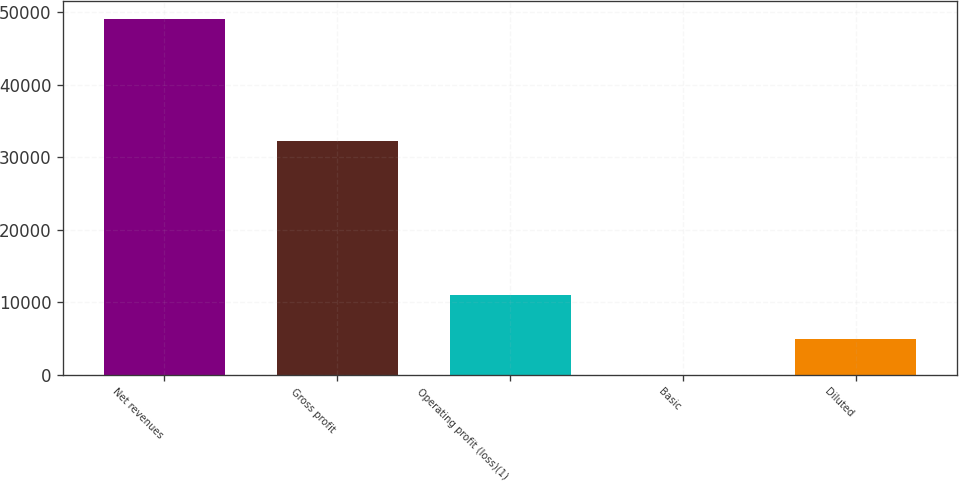Convert chart to OTSL. <chart><loc_0><loc_0><loc_500><loc_500><bar_chart><fcel>Net revenues<fcel>Gross profit<fcel>Operating profit (loss)(1)<fcel>Basic<fcel>Diluted<nl><fcel>49034<fcel>32245<fcel>10965<fcel>0.16<fcel>4903.54<nl></chart> 